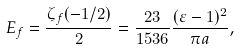Convert formula to latex. <formula><loc_0><loc_0><loc_500><loc_500>E _ { f } = \frac { \zeta _ { f } ( - 1 / 2 ) } { 2 } = \frac { 2 3 } { 1 5 3 6 } \frac { ( \varepsilon - 1 ) ^ { 2 } } { \pi a } ,</formula> 